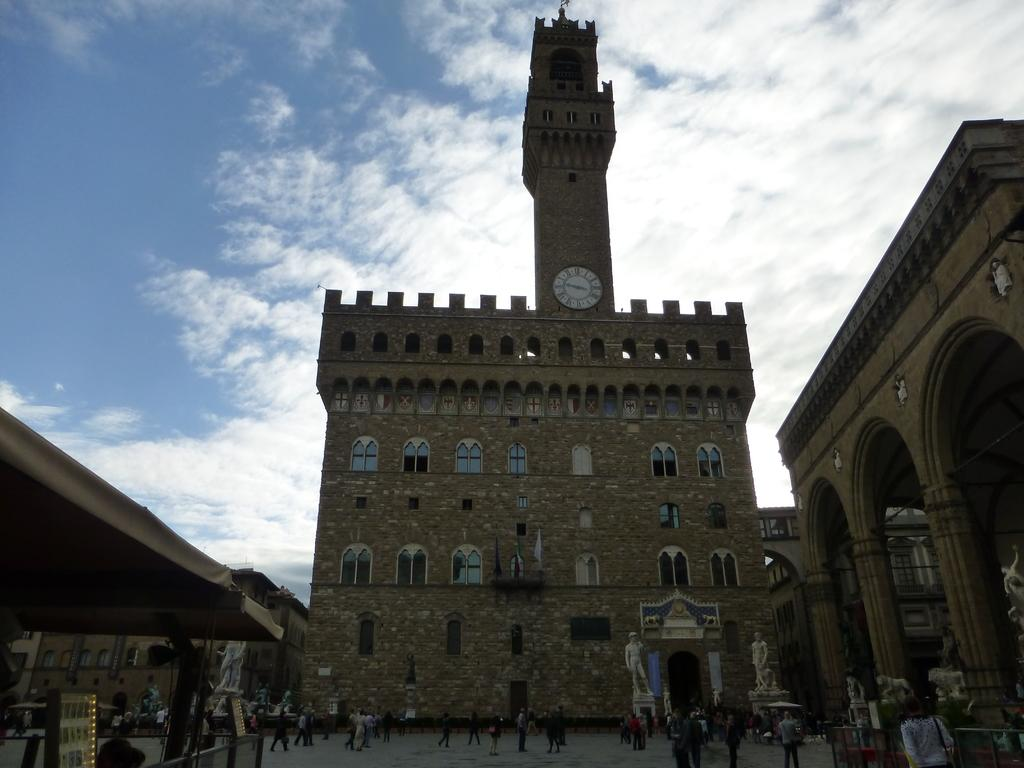What is located in the center of the image? There are buildings in the center of the image. What can be seen at the bottom of the image? There are statues at the bottom of the image. What are the people in the image doing? There are many people walking in the image. What is visible at the top of the image? The sky is visible at the top of the image. Where is the tent located in the image? The tent is on the left side of the image. What reason does the grandfather have for visiting the statues in the image? There is no mention of a grandfather or any specific reason for visiting the statues in the image. 